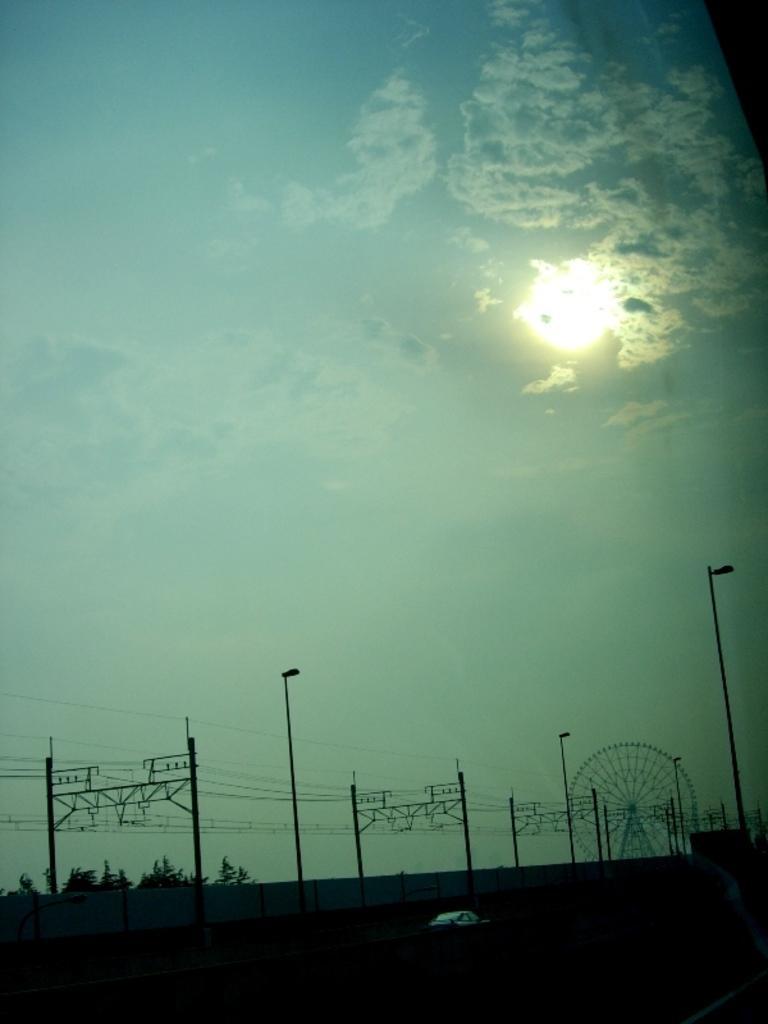How would you summarize this image in a sentence or two? In this image there is a car. There is a giant wheel. There are street lights. There are current polls. There are trees. There is a wall. In the background of the image there is sky and a moon. 